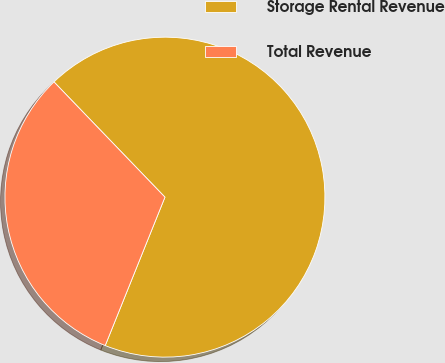Convert chart. <chart><loc_0><loc_0><loc_500><loc_500><pie_chart><fcel>Storage Rental Revenue<fcel>Total Revenue<nl><fcel>68.29%<fcel>31.71%<nl></chart> 